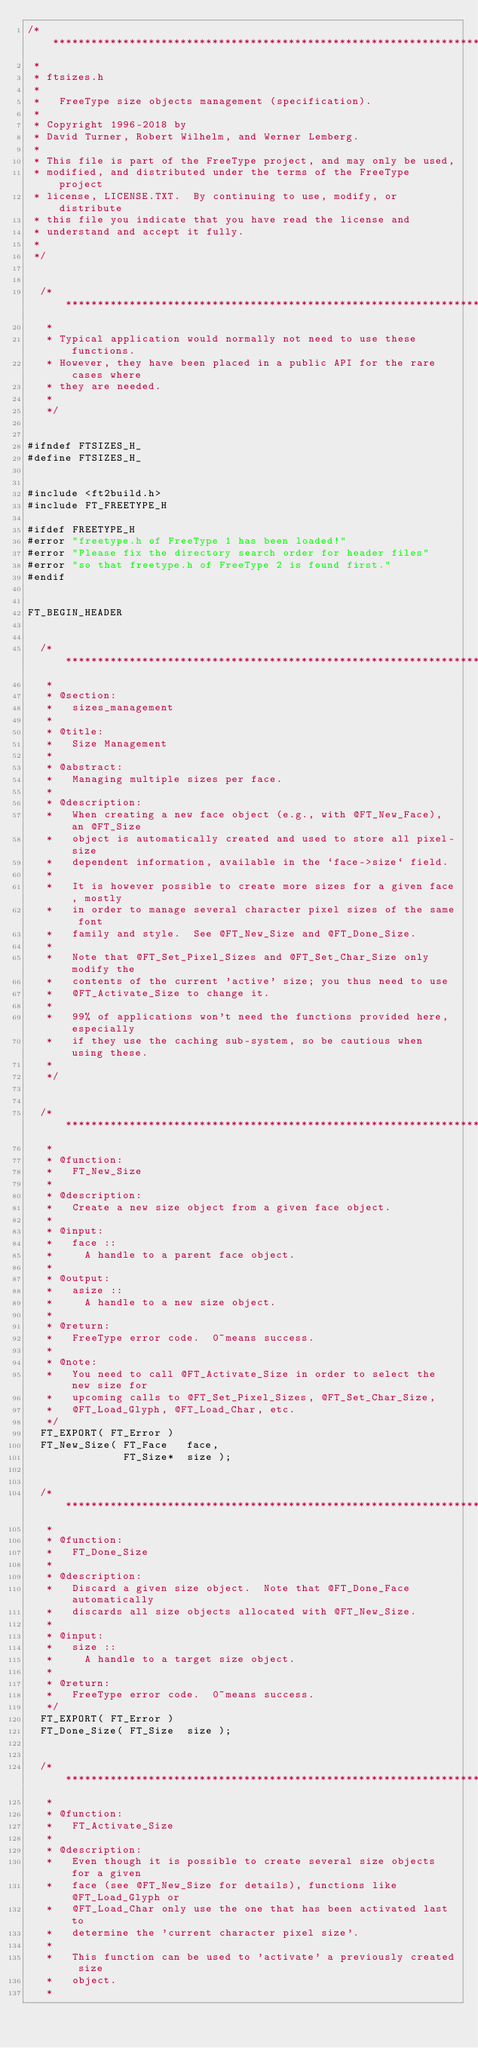<code> <loc_0><loc_0><loc_500><loc_500><_C_>/****************************************************************************
 *
 * ftsizes.h
 *
 *   FreeType size objects management (specification).
 *
 * Copyright 1996-2018 by
 * David Turner, Robert Wilhelm, and Werner Lemberg.
 *
 * This file is part of the FreeType project, and may only be used,
 * modified, and distributed under the terms of the FreeType project
 * license, LICENSE.TXT.  By continuing to use, modify, or distribute
 * this file you indicate that you have read the license and
 * understand and accept it fully.
 *
 */


  /**************************************************************************
   *
   * Typical application would normally not need to use these functions.
   * However, they have been placed in a public API for the rare cases where
   * they are needed.
   *
   */


#ifndef FTSIZES_H_
#define FTSIZES_H_


#include <ft2build.h>
#include FT_FREETYPE_H

#ifdef FREETYPE_H
#error "freetype.h of FreeType 1 has been loaded!"
#error "Please fix the directory search order for header files"
#error "so that freetype.h of FreeType 2 is found first."
#endif


FT_BEGIN_HEADER


  /**************************************************************************
   *
   * @section:
   *   sizes_management
   *
   * @title:
   *   Size Management
   *
   * @abstract:
   *   Managing multiple sizes per face.
   *
   * @description:
   *   When creating a new face object (e.g., with @FT_New_Face), an @FT_Size
   *   object is automatically created and used to store all pixel-size
   *   dependent information, available in the `face->size` field.
   *
   *   It is however possible to create more sizes for a given face, mostly
   *   in order to manage several character pixel sizes of the same font
   *   family and style.  See @FT_New_Size and @FT_Done_Size.
   *
   *   Note that @FT_Set_Pixel_Sizes and @FT_Set_Char_Size only modify the
   *   contents of the current 'active' size; you thus need to use
   *   @FT_Activate_Size to change it.
   *
   *   99% of applications won't need the functions provided here, especially
   *   if they use the caching sub-system, so be cautious when using these.
   *
   */


  /**************************************************************************
   *
   * @function:
   *   FT_New_Size
   *
   * @description:
   *   Create a new size object from a given face object.
   *
   * @input:
   *   face ::
   *     A handle to a parent face object.
   *
   * @output:
   *   asize ::
   *     A handle to a new size object.
   *
   * @return:
   *   FreeType error code.  0~means success.
   *
   * @note:
   *   You need to call @FT_Activate_Size in order to select the new size for
   *   upcoming calls to @FT_Set_Pixel_Sizes, @FT_Set_Char_Size,
   *   @FT_Load_Glyph, @FT_Load_Char, etc.
   */
  FT_EXPORT( FT_Error )
  FT_New_Size( FT_Face   face,
               FT_Size*  size );


  /**************************************************************************
   *
   * @function:
   *   FT_Done_Size
   *
   * @description:
   *   Discard a given size object.  Note that @FT_Done_Face automatically
   *   discards all size objects allocated with @FT_New_Size.
   *
   * @input:
   *   size ::
   *     A handle to a target size object.
   *
   * @return:
   *   FreeType error code.  0~means success.
   */
  FT_EXPORT( FT_Error )
  FT_Done_Size( FT_Size  size );


  /**************************************************************************
   *
   * @function:
   *   FT_Activate_Size
   *
   * @description:
   *   Even though it is possible to create several size objects for a given
   *   face (see @FT_New_Size for details), functions like @FT_Load_Glyph or
   *   @FT_Load_Char only use the one that has been activated last to
   *   determine the 'current character pixel size'.
   *
   *   This function can be used to 'activate' a previously created size
   *   object.
   *</code> 